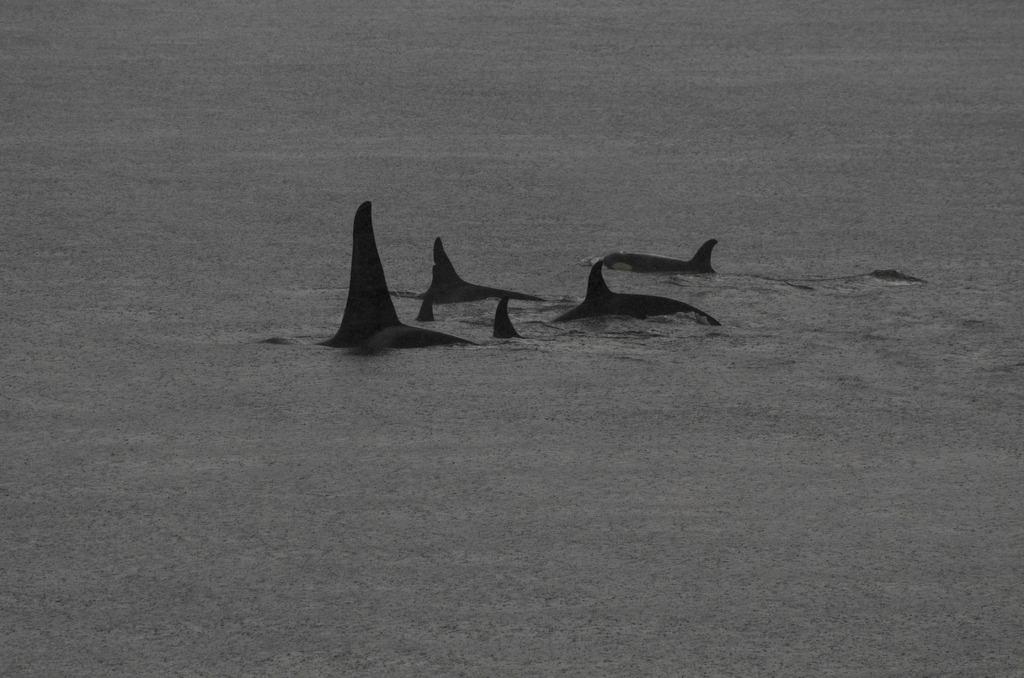What type of animals are in the image? There are fishes in the image. Where are the fishes located? The fishes are in the water. What type of hose is being used by the fishes in the image? There is no hose present in the image; the fishes are in the water. How many hands can be seen interacting with the fishes in the image? There are no hands visible in the image; it only shows fishes in the water. 